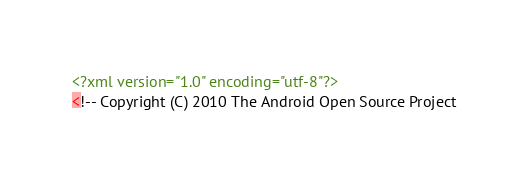Convert code to text. <code><loc_0><loc_0><loc_500><loc_500><_XML_><?xml version="1.0" encoding="utf-8"?>
<!-- Copyright (C) 2010 The Android Open Source Project
</code> 